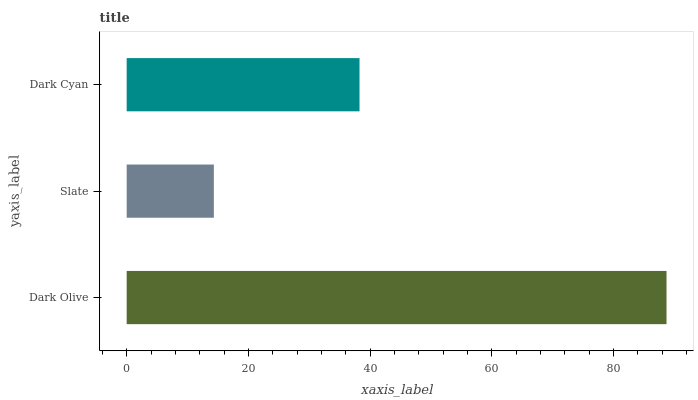Is Slate the minimum?
Answer yes or no. Yes. Is Dark Olive the maximum?
Answer yes or no. Yes. Is Dark Cyan the minimum?
Answer yes or no. No. Is Dark Cyan the maximum?
Answer yes or no. No. Is Dark Cyan greater than Slate?
Answer yes or no. Yes. Is Slate less than Dark Cyan?
Answer yes or no. Yes. Is Slate greater than Dark Cyan?
Answer yes or no. No. Is Dark Cyan less than Slate?
Answer yes or no. No. Is Dark Cyan the high median?
Answer yes or no. Yes. Is Dark Cyan the low median?
Answer yes or no. Yes. Is Slate the high median?
Answer yes or no. No. Is Dark Olive the low median?
Answer yes or no. No. 